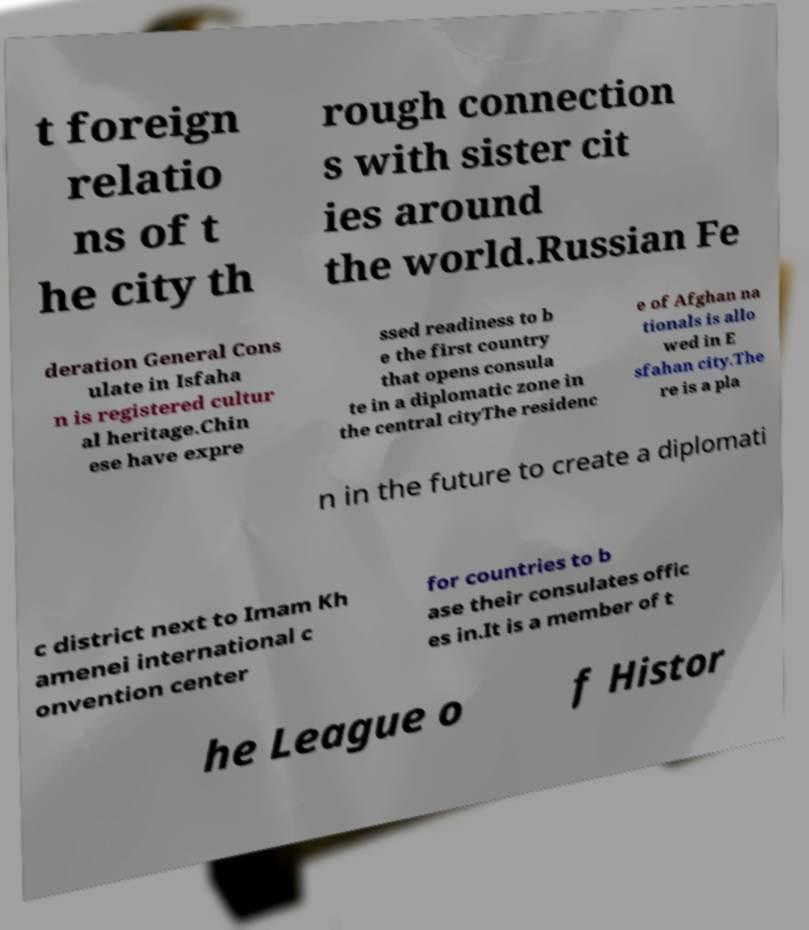I need the written content from this picture converted into text. Can you do that? t foreign relatio ns of t he city th rough connection s with sister cit ies around the world.Russian Fe deration General Cons ulate in Isfaha n is registered cultur al heritage.Chin ese have expre ssed readiness to b e the first country that opens consula te in a diplomatic zone in the central cityThe residenc e of Afghan na tionals is allo wed in E sfahan city.The re is a pla n in the future to create a diplomati c district next to Imam Kh amenei international c onvention center for countries to b ase their consulates offic es in.It is a member of t he League o f Histor 